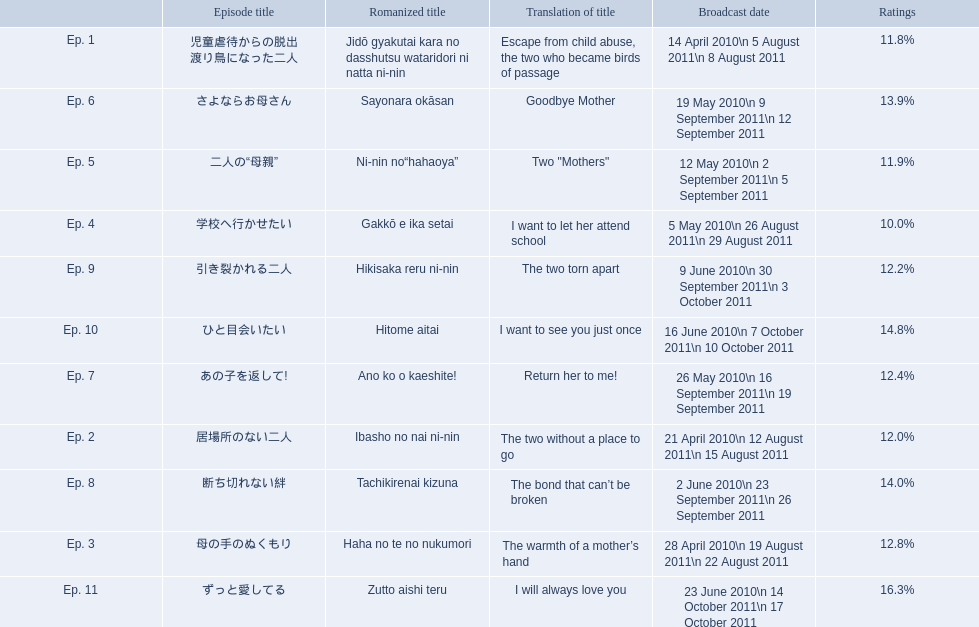How many total episodes are there? Ep. 1, Ep. 2, Ep. 3, Ep. 4, Ep. 5, Ep. 6, Ep. 7, Ep. 8, Ep. 9, Ep. 10, Ep. 11. Of those episodes, which one has the title of the bond that can't be broken? Ep. 8. What was the ratings percentage for that episode? 14.0%. Which episode was titled the two without a place to go? Ep. 2. What was the title of ep. 3? The warmth of a mother’s hand. Which episode had a rating of 10.0%? Ep. 4. 